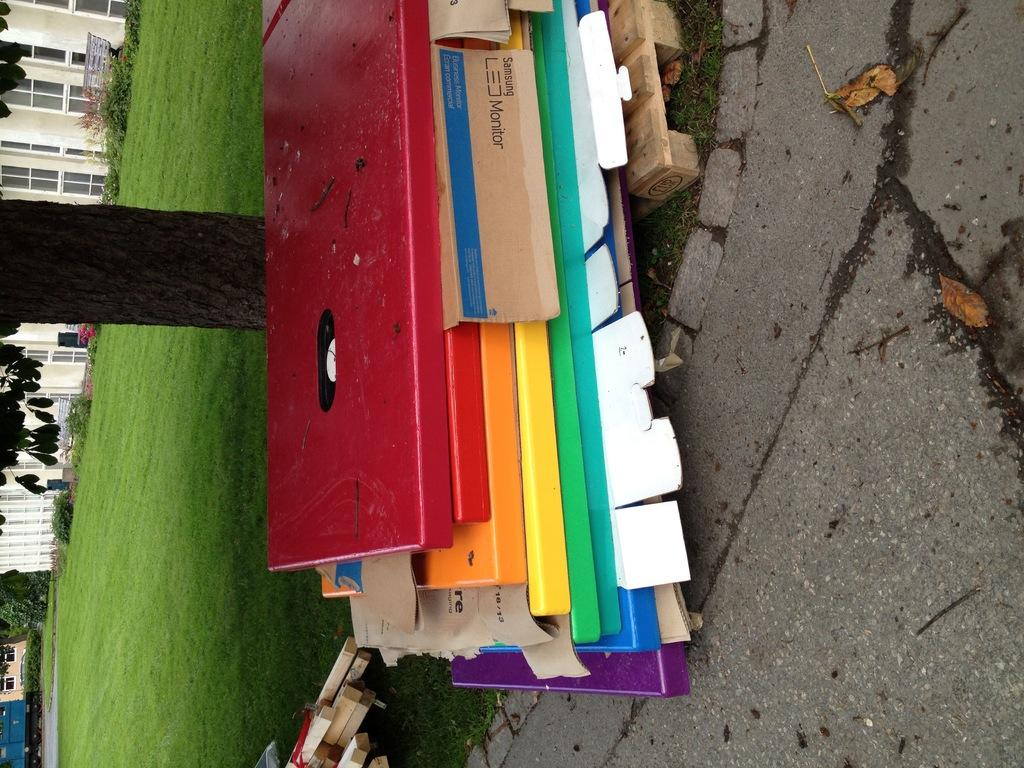What is: What is placed on the ground in the image? There are wooden planks placed on the ground in the image. How can the wooden planks be distinguished from one another? The wooden planks are in different colors. What can be seen on the left side of the image? There is a tree on the left side of the image. What structure is visible in the background of the image? There is a house in the background of the image. Can you compare the taste of the grapes with the color of the wooden planks in the image? There are no grapes present in the image, so it is not possible to compare their taste with the color of the wooden planks. 